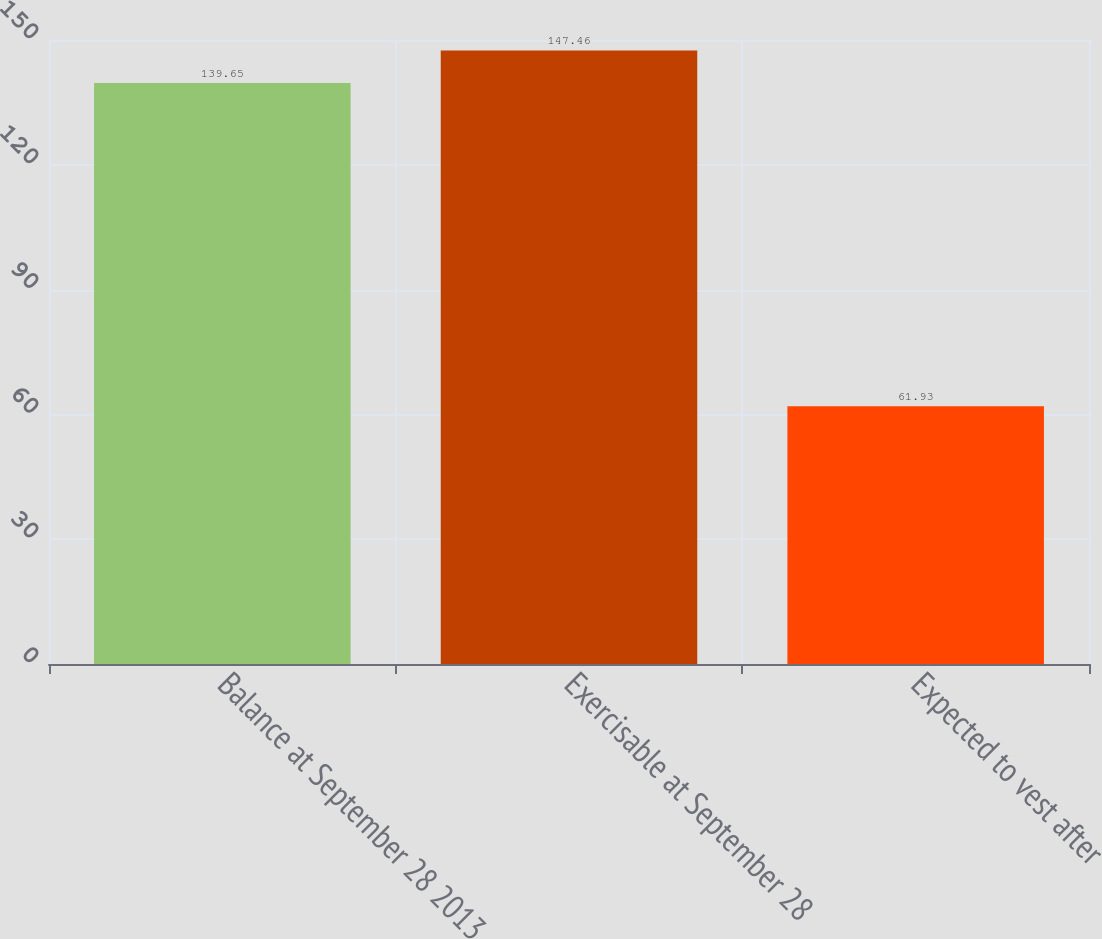Convert chart to OTSL. <chart><loc_0><loc_0><loc_500><loc_500><bar_chart><fcel>Balance at September 28 2013<fcel>Exercisable at September 28<fcel>Expected to vest after<nl><fcel>139.65<fcel>147.46<fcel>61.93<nl></chart> 